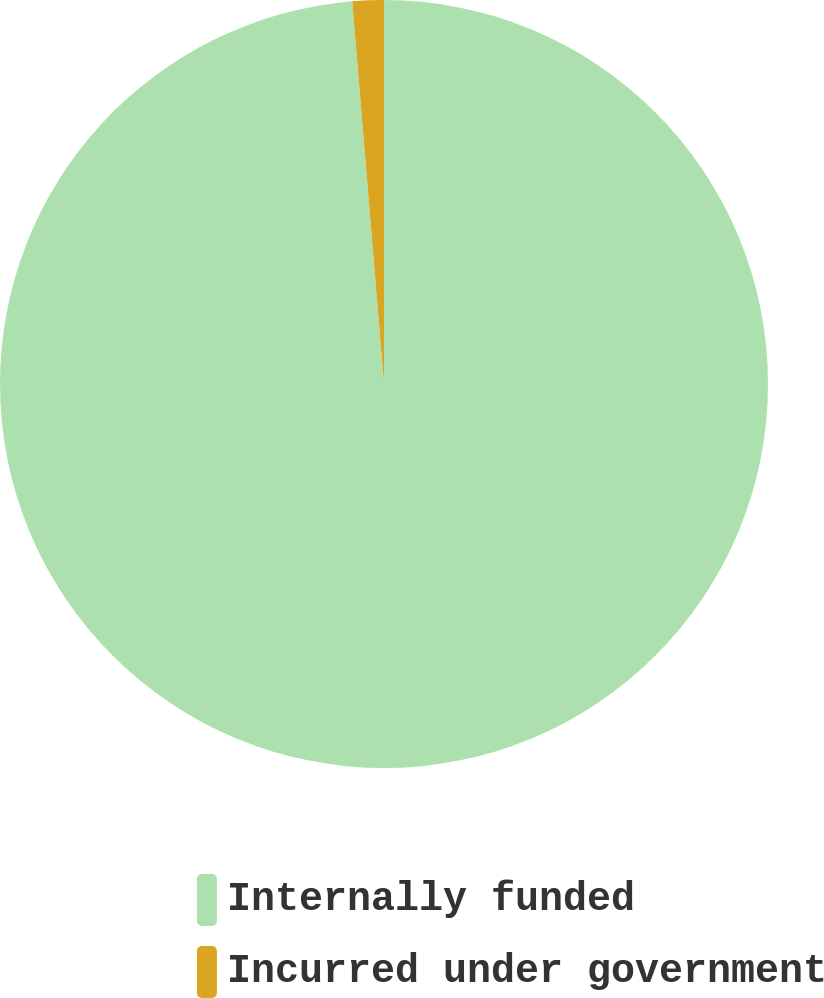<chart> <loc_0><loc_0><loc_500><loc_500><pie_chart><fcel>Internally funded<fcel>Incurred under government<nl><fcel>98.68%<fcel>1.32%<nl></chart> 